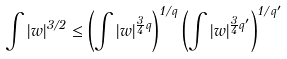<formula> <loc_0><loc_0><loc_500><loc_500>\int | w | ^ { 3 / 2 } \leq \left ( \int | w | ^ { \frac { 3 } { 4 } q } \right ) ^ { 1 / q } \left ( \int | w | ^ { \frac { 3 } { 4 } q ^ { \prime } } \right ) ^ { 1 / q ^ { \prime } }</formula> 